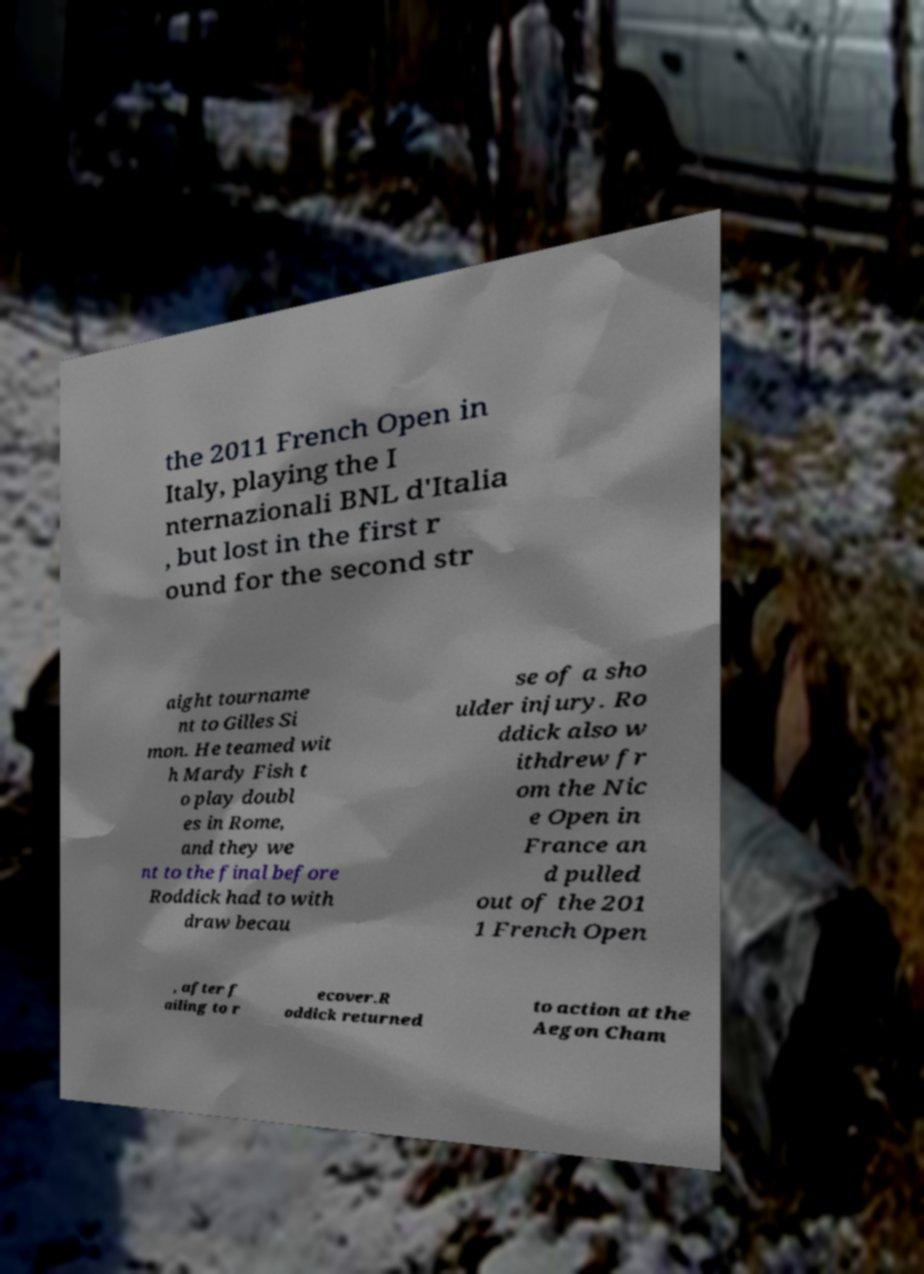Please read and relay the text visible in this image. What does it say? the 2011 French Open in Italy, playing the I nternazionali BNL d'Italia , but lost in the first r ound for the second str aight tourname nt to Gilles Si mon. He teamed wit h Mardy Fish t o play doubl es in Rome, and they we nt to the final before Roddick had to with draw becau se of a sho ulder injury. Ro ddick also w ithdrew fr om the Nic e Open in France an d pulled out of the 201 1 French Open , after f ailing to r ecover.R oddick returned to action at the Aegon Cham 